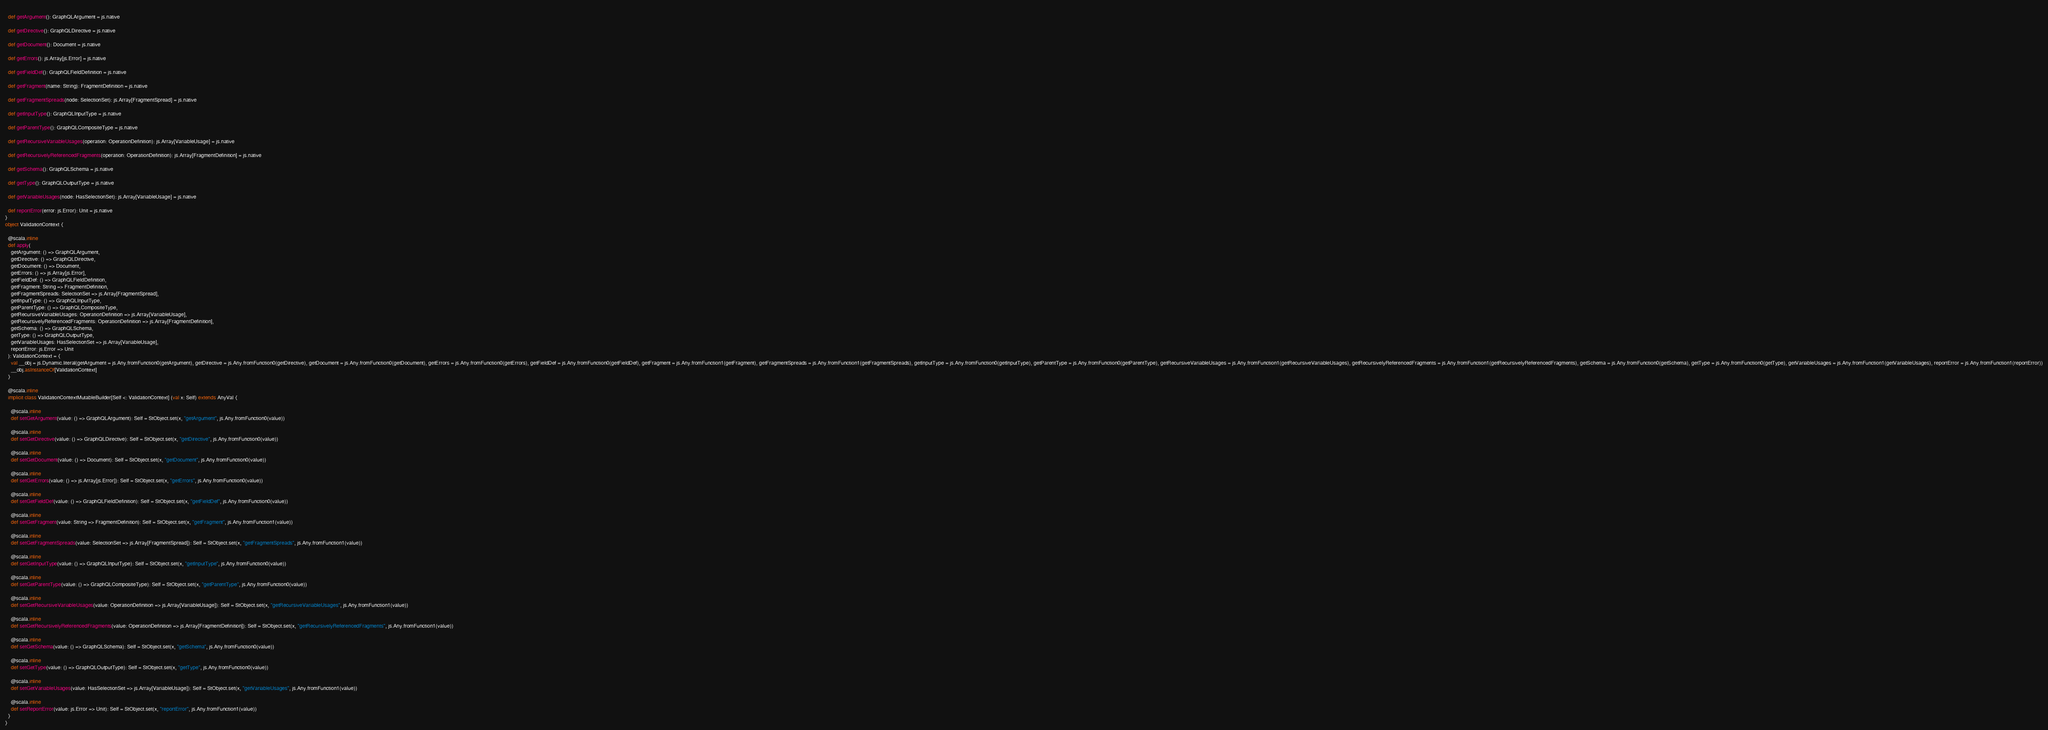<code> <loc_0><loc_0><loc_500><loc_500><_Scala_>  
  def getArgument(): GraphQLArgument = js.native
  
  def getDirective(): GraphQLDirective = js.native
  
  def getDocument(): Document = js.native
  
  def getErrors(): js.Array[js.Error] = js.native
  
  def getFieldDef(): GraphQLFieldDefinition = js.native
  
  def getFragment(name: String): FragmentDefinition = js.native
  
  def getFragmentSpreads(node: SelectionSet): js.Array[FragmentSpread] = js.native
  
  def getInputType(): GraphQLInputType = js.native
  
  def getParentType(): GraphQLCompositeType = js.native
  
  def getRecursiveVariableUsages(operation: OperationDefinition): js.Array[VariableUsage] = js.native
  
  def getRecursivelyReferencedFragments(operation: OperationDefinition): js.Array[FragmentDefinition] = js.native
  
  def getSchema(): GraphQLSchema = js.native
  
  def getType(): GraphQLOutputType = js.native
  
  def getVariableUsages(node: HasSelectionSet): js.Array[VariableUsage] = js.native
  
  def reportError(error: js.Error): Unit = js.native
}
object ValidationContext {
  
  @scala.inline
  def apply(
    getArgument: () => GraphQLArgument,
    getDirective: () => GraphQLDirective,
    getDocument: () => Document,
    getErrors: () => js.Array[js.Error],
    getFieldDef: () => GraphQLFieldDefinition,
    getFragment: String => FragmentDefinition,
    getFragmentSpreads: SelectionSet => js.Array[FragmentSpread],
    getInputType: () => GraphQLInputType,
    getParentType: () => GraphQLCompositeType,
    getRecursiveVariableUsages: OperationDefinition => js.Array[VariableUsage],
    getRecursivelyReferencedFragments: OperationDefinition => js.Array[FragmentDefinition],
    getSchema: () => GraphQLSchema,
    getType: () => GraphQLOutputType,
    getVariableUsages: HasSelectionSet => js.Array[VariableUsage],
    reportError: js.Error => Unit
  ): ValidationContext = {
    val __obj = js.Dynamic.literal(getArgument = js.Any.fromFunction0(getArgument), getDirective = js.Any.fromFunction0(getDirective), getDocument = js.Any.fromFunction0(getDocument), getErrors = js.Any.fromFunction0(getErrors), getFieldDef = js.Any.fromFunction0(getFieldDef), getFragment = js.Any.fromFunction1(getFragment), getFragmentSpreads = js.Any.fromFunction1(getFragmentSpreads), getInputType = js.Any.fromFunction0(getInputType), getParentType = js.Any.fromFunction0(getParentType), getRecursiveVariableUsages = js.Any.fromFunction1(getRecursiveVariableUsages), getRecursivelyReferencedFragments = js.Any.fromFunction1(getRecursivelyReferencedFragments), getSchema = js.Any.fromFunction0(getSchema), getType = js.Any.fromFunction0(getType), getVariableUsages = js.Any.fromFunction1(getVariableUsages), reportError = js.Any.fromFunction1(reportError))
    __obj.asInstanceOf[ValidationContext]
  }
  
  @scala.inline
  implicit class ValidationContextMutableBuilder[Self <: ValidationContext] (val x: Self) extends AnyVal {
    
    @scala.inline
    def setGetArgument(value: () => GraphQLArgument): Self = StObject.set(x, "getArgument", js.Any.fromFunction0(value))
    
    @scala.inline
    def setGetDirective(value: () => GraphQLDirective): Self = StObject.set(x, "getDirective", js.Any.fromFunction0(value))
    
    @scala.inline
    def setGetDocument(value: () => Document): Self = StObject.set(x, "getDocument", js.Any.fromFunction0(value))
    
    @scala.inline
    def setGetErrors(value: () => js.Array[js.Error]): Self = StObject.set(x, "getErrors", js.Any.fromFunction0(value))
    
    @scala.inline
    def setGetFieldDef(value: () => GraphQLFieldDefinition): Self = StObject.set(x, "getFieldDef", js.Any.fromFunction0(value))
    
    @scala.inline
    def setGetFragment(value: String => FragmentDefinition): Self = StObject.set(x, "getFragment", js.Any.fromFunction1(value))
    
    @scala.inline
    def setGetFragmentSpreads(value: SelectionSet => js.Array[FragmentSpread]): Self = StObject.set(x, "getFragmentSpreads", js.Any.fromFunction1(value))
    
    @scala.inline
    def setGetInputType(value: () => GraphQLInputType): Self = StObject.set(x, "getInputType", js.Any.fromFunction0(value))
    
    @scala.inline
    def setGetParentType(value: () => GraphQLCompositeType): Self = StObject.set(x, "getParentType", js.Any.fromFunction0(value))
    
    @scala.inline
    def setGetRecursiveVariableUsages(value: OperationDefinition => js.Array[VariableUsage]): Self = StObject.set(x, "getRecursiveVariableUsages", js.Any.fromFunction1(value))
    
    @scala.inline
    def setGetRecursivelyReferencedFragments(value: OperationDefinition => js.Array[FragmentDefinition]): Self = StObject.set(x, "getRecursivelyReferencedFragments", js.Any.fromFunction1(value))
    
    @scala.inline
    def setGetSchema(value: () => GraphQLSchema): Self = StObject.set(x, "getSchema", js.Any.fromFunction0(value))
    
    @scala.inline
    def setGetType(value: () => GraphQLOutputType): Self = StObject.set(x, "getType", js.Any.fromFunction0(value))
    
    @scala.inline
    def setGetVariableUsages(value: HasSelectionSet => js.Array[VariableUsage]): Self = StObject.set(x, "getVariableUsages", js.Any.fromFunction1(value))
    
    @scala.inline
    def setReportError(value: js.Error => Unit): Self = StObject.set(x, "reportError", js.Any.fromFunction1(value))
  }
}
</code> 